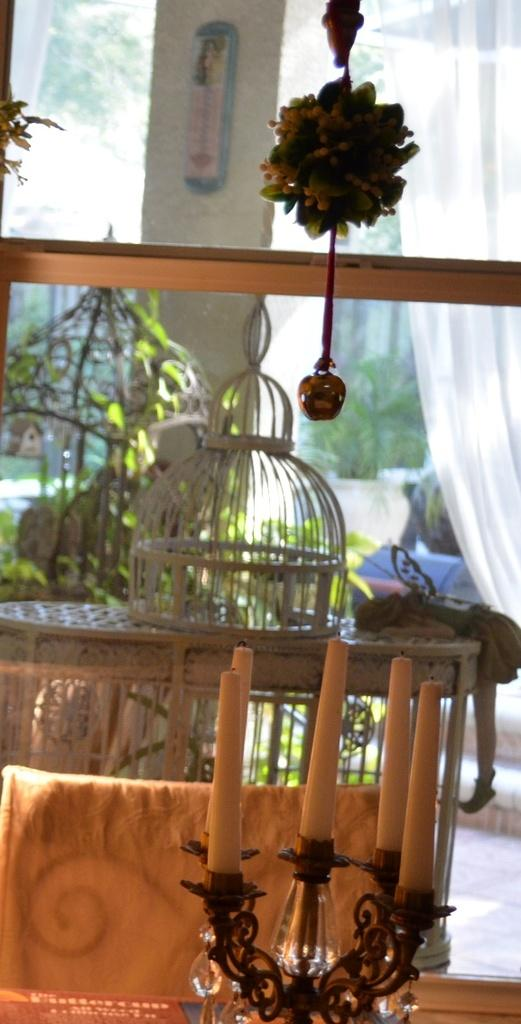What is located at the bottom of the image? There is a candle stand at the bottom of the image. What is in the middle of the image? There is a table at the center of the image. What type of vegetation is present in the image? There are plants in the image. What can be seen in the background of the image? There is a glass window in the image. What type of event is taking place in the image? There is no indication of an event taking place in the image. Can you tell me how many matches are visible in the image? There are no matches present in the image. 